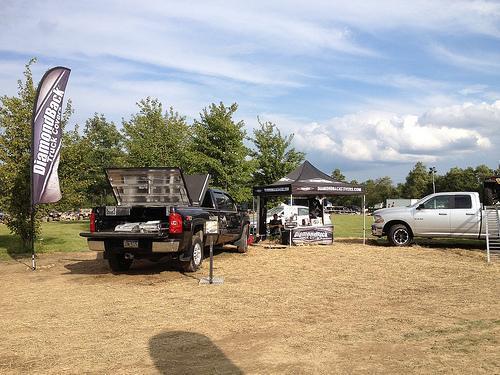How many trucks are there in the picture?
Give a very brief answer. 2. 